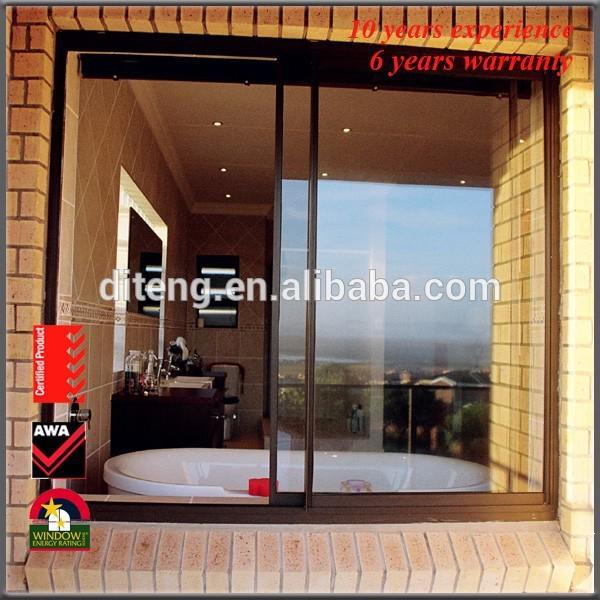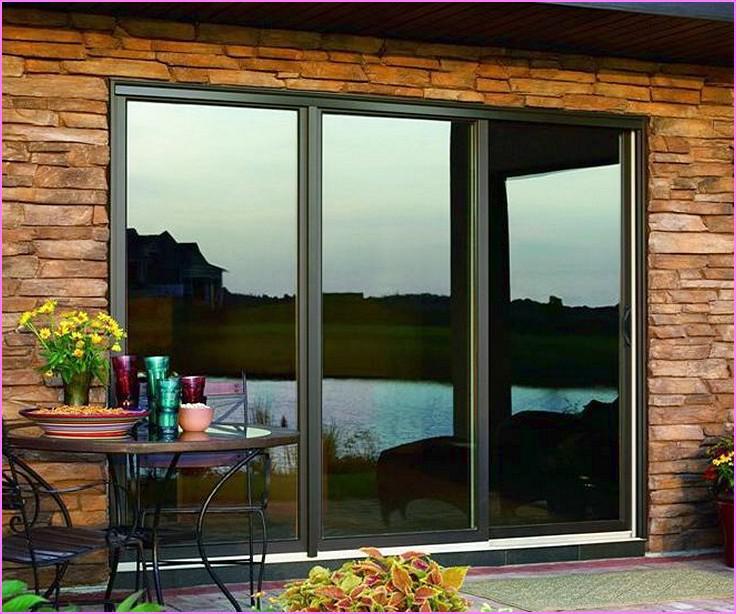The first image is the image on the left, the second image is the image on the right. For the images shown, is this caption "Three equal size segments make up each glass door and window panel installation with discreet door hardware visible on one panel." true? Answer yes or no. No. 